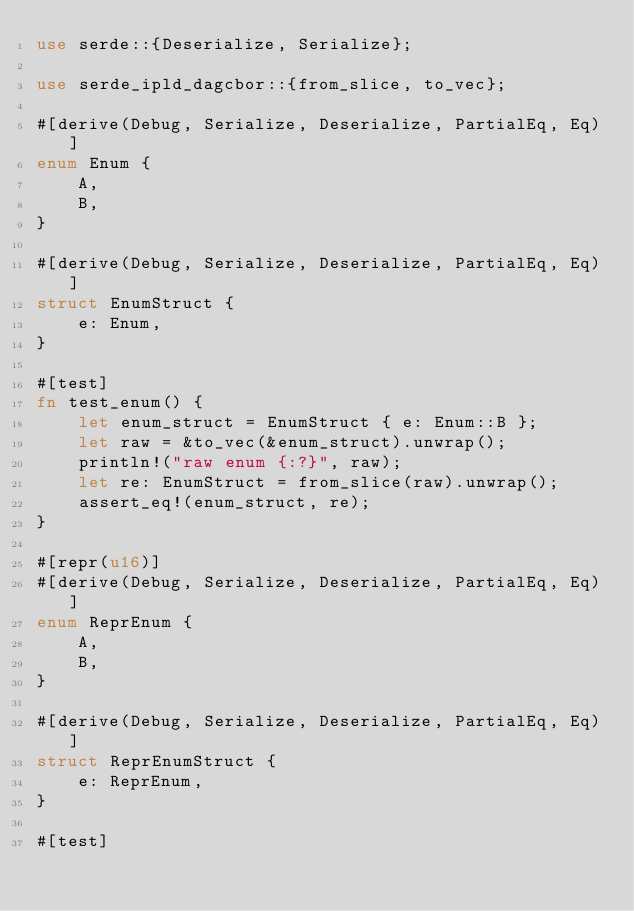<code> <loc_0><loc_0><loc_500><loc_500><_Rust_>use serde::{Deserialize, Serialize};

use serde_ipld_dagcbor::{from_slice, to_vec};

#[derive(Debug, Serialize, Deserialize, PartialEq, Eq)]
enum Enum {
    A,
    B,
}

#[derive(Debug, Serialize, Deserialize, PartialEq, Eq)]
struct EnumStruct {
    e: Enum,
}

#[test]
fn test_enum() {
    let enum_struct = EnumStruct { e: Enum::B };
    let raw = &to_vec(&enum_struct).unwrap();
    println!("raw enum {:?}", raw);
    let re: EnumStruct = from_slice(raw).unwrap();
    assert_eq!(enum_struct, re);
}

#[repr(u16)]
#[derive(Debug, Serialize, Deserialize, PartialEq, Eq)]
enum ReprEnum {
    A,
    B,
}

#[derive(Debug, Serialize, Deserialize, PartialEq, Eq)]
struct ReprEnumStruct {
    e: ReprEnum,
}

#[test]</code> 